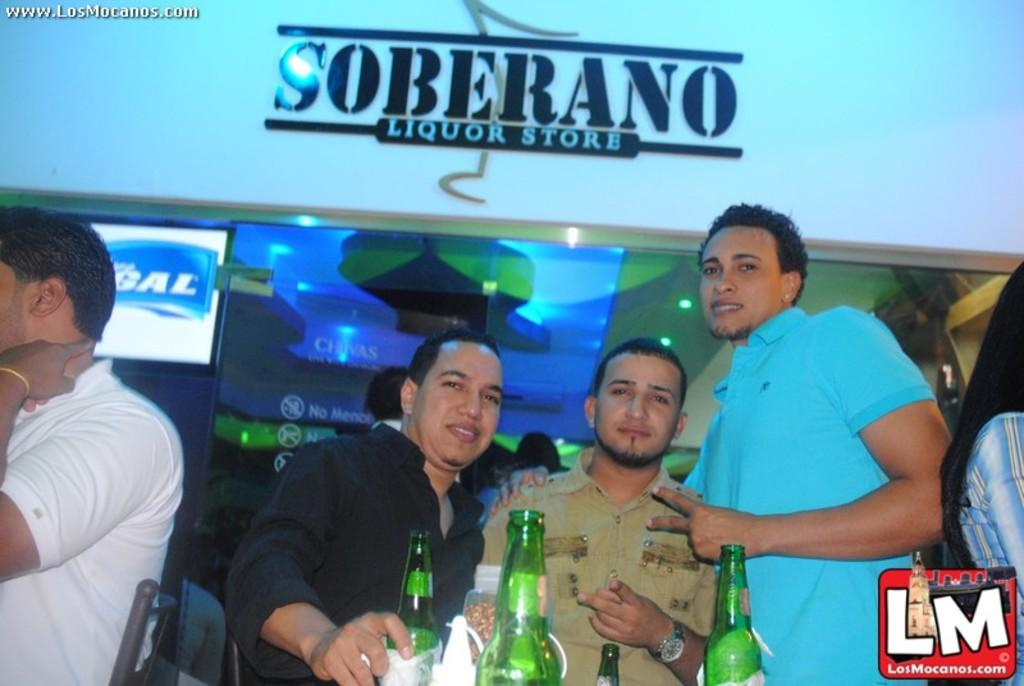<image>
Render a clear and concise summary of the photo. A group of men standing under the soberano liquor store sign. 